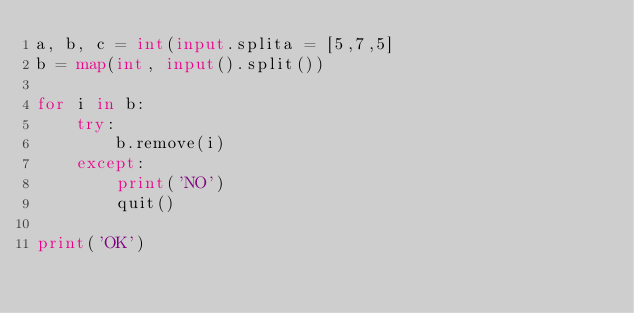<code> <loc_0><loc_0><loc_500><loc_500><_Python_>a, b, c = int(input.splita = [5,7,5]
b = map(int, input().split())

for i in b:
    try:
        b.remove(i)
    except:
        print('NO')
        quit()

print('OK')</code> 